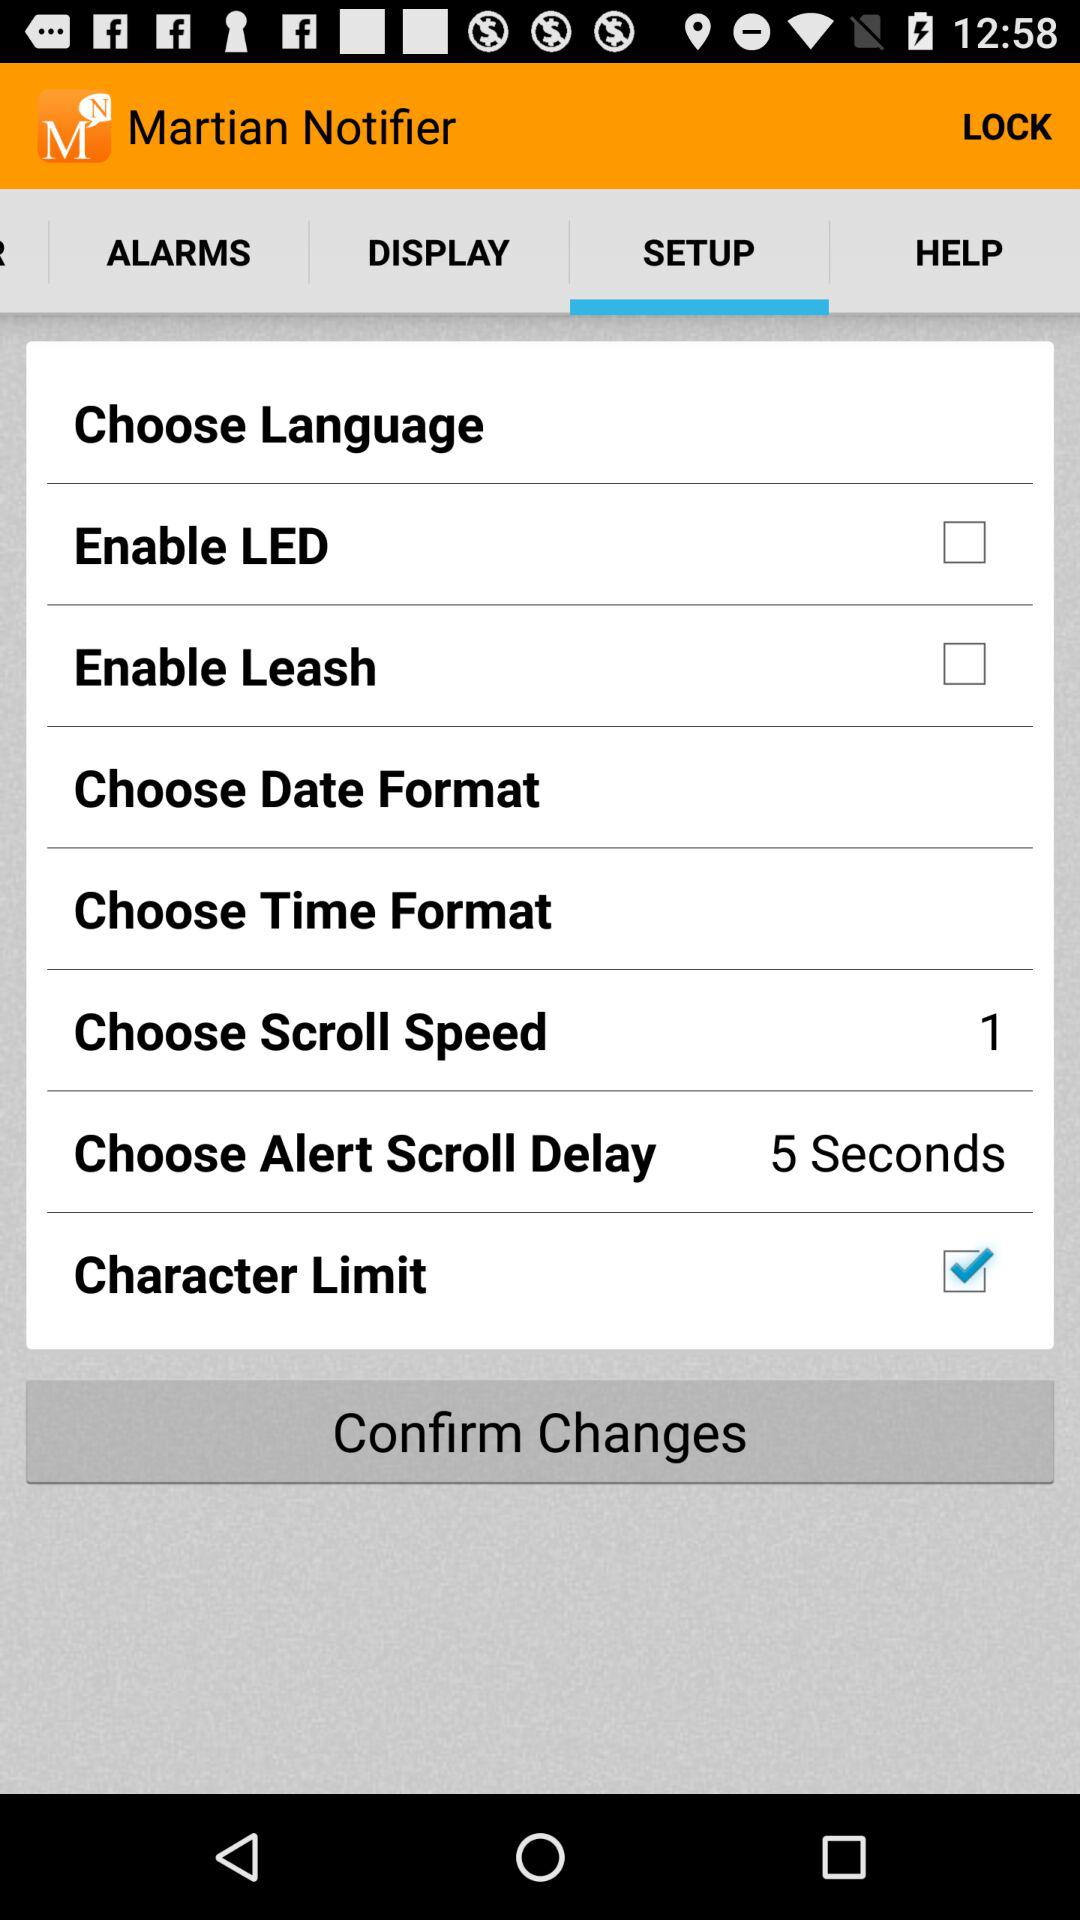How many "Choose Scroll Speed" are there? There is one "Choose Scroll Speed". 